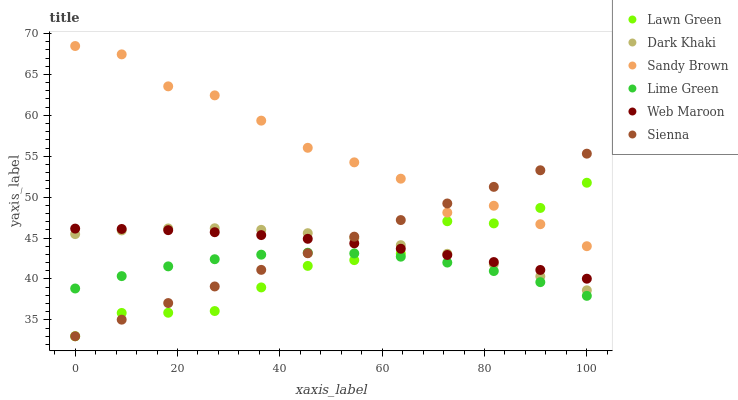Does Lime Green have the minimum area under the curve?
Answer yes or no. Yes. Does Sandy Brown have the maximum area under the curve?
Answer yes or no. Yes. Does Web Maroon have the minimum area under the curve?
Answer yes or no. No. Does Web Maroon have the maximum area under the curve?
Answer yes or no. No. Is Sienna the smoothest?
Answer yes or no. Yes. Is Sandy Brown the roughest?
Answer yes or no. Yes. Is Lime Green the smoothest?
Answer yes or no. No. Is Lime Green the roughest?
Answer yes or no. No. Does Lawn Green have the lowest value?
Answer yes or no. Yes. Does Lime Green have the lowest value?
Answer yes or no. No. Does Sandy Brown have the highest value?
Answer yes or no. Yes. Does Web Maroon have the highest value?
Answer yes or no. No. Is Dark Khaki less than Sandy Brown?
Answer yes or no. Yes. Is Sandy Brown greater than Dark Khaki?
Answer yes or no. Yes. Does Lawn Green intersect Sienna?
Answer yes or no. Yes. Is Lawn Green less than Sienna?
Answer yes or no. No. Is Lawn Green greater than Sienna?
Answer yes or no. No. Does Dark Khaki intersect Sandy Brown?
Answer yes or no. No. 